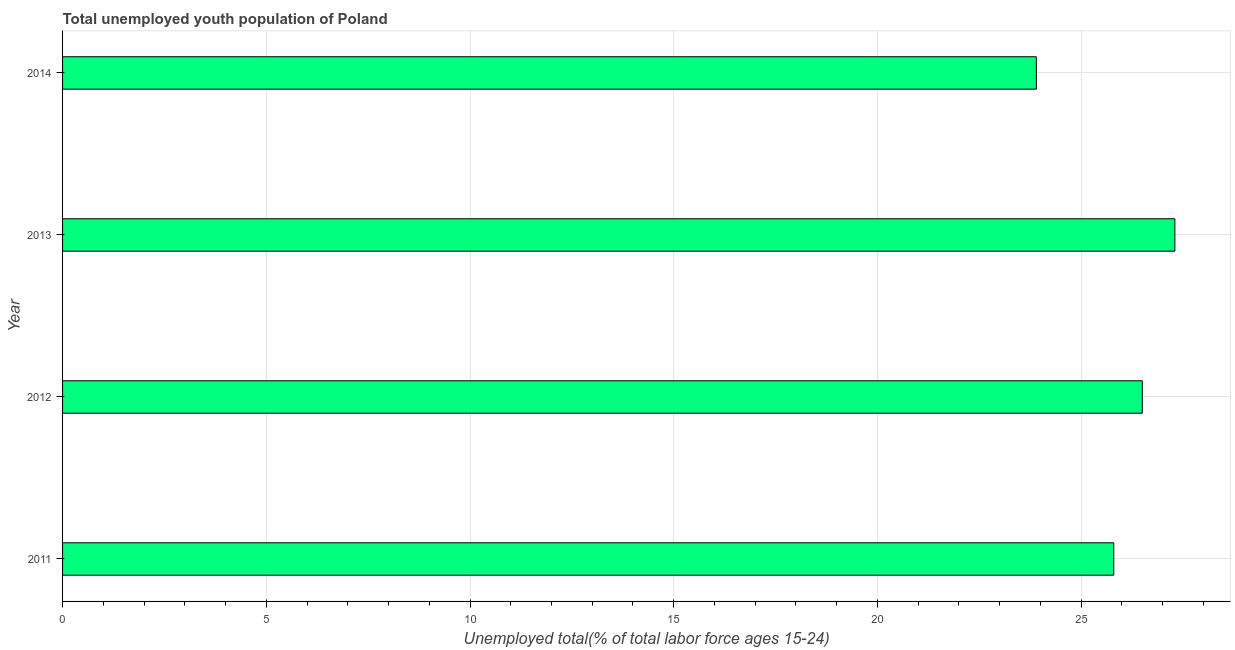What is the title of the graph?
Ensure brevity in your answer.  Total unemployed youth population of Poland. What is the label or title of the X-axis?
Offer a very short reply. Unemployed total(% of total labor force ages 15-24). What is the label or title of the Y-axis?
Keep it short and to the point. Year. What is the unemployed youth in 2011?
Provide a short and direct response. 25.8. Across all years, what is the maximum unemployed youth?
Your answer should be very brief. 27.3. Across all years, what is the minimum unemployed youth?
Offer a terse response. 23.9. What is the sum of the unemployed youth?
Offer a terse response. 103.5. What is the difference between the unemployed youth in 2011 and 2012?
Your answer should be compact. -0.7. What is the average unemployed youth per year?
Provide a succinct answer. 25.88. What is the median unemployed youth?
Make the answer very short. 26.15. Do a majority of the years between 2011 and 2012 (inclusive) have unemployed youth greater than 2 %?
Give a very brief answer. Yes. What is the ratio of the unemployed youth in 2011 to that in 2012?
Keep it short and to the point. 0.97. What is the difference between the highest and the second highest unemployed youth?
Your answer should be compact. 0.8. Is the sum of the unemployed youth in 2013 and 2014 greater than the maximum unemployed youth across all years?
Your answer should be compact. Yes. Are all the bars in the graph horizontal?
Your response must be concise. Yes. How many years are there in the graph?
Offer a very short reply. 4. What is the difference between two consecutive major ticks on the X-axis?
Keep it short and to the point. 5. Are the values on the major ticks of X-axis written in scientific E-notation?
Offer a very short reply. No. What is the Unemployed total(% of total labor force ages 15-24) of 2011?
Offer a terse response. 25.8. What is the Unemployed total(% of total labor force ages 15-24) of 2013?
Offer a terse response. 27.3. What is the Unemployed total(% of total labor force ages 15-24) of 2014?
Give a very brief answer. 23.9. What is the difference between the Unemployed total(% of total labor force ages 15-24) in 2011 and 2012?
Ensure brevity in your answer.  -0.7. What is the difference between the Unemployed total(% of total labor force ages 15-24) in 2011 and 2014?
Ensure brevity in your answer.  1.9. What is the difference between the Unemployed total(% of total labor force ages 15-24) in 2013 and 2014?
Offer a terse response. 3.4. What is the ratio of the Unemployed total(% of total labor force ages 15-24) in 2011 to that in 2012?
Your answer should be very brief. 0.97. What is the ratio of the Unemployed total(% of total labor force ages 15-24) in 2011 to that in 2013?
Give a very brief answer. 0.94. What is the ratio of the Unemployed total(% of total labor force ages 15-24) in 2011 to that in 2014?
Ensure brevity in your answer.  1.08. What is the ratio of the Unemployed total(% of total labor force ages 15-24) in 2012 to that in 2014?
Give a very brief answer. 1.11. What is the ratio of the Unemployed total(% of total labor force ages 15-24) in 2013 to that in 2014?
Keep it short and to the point. 1.14. 